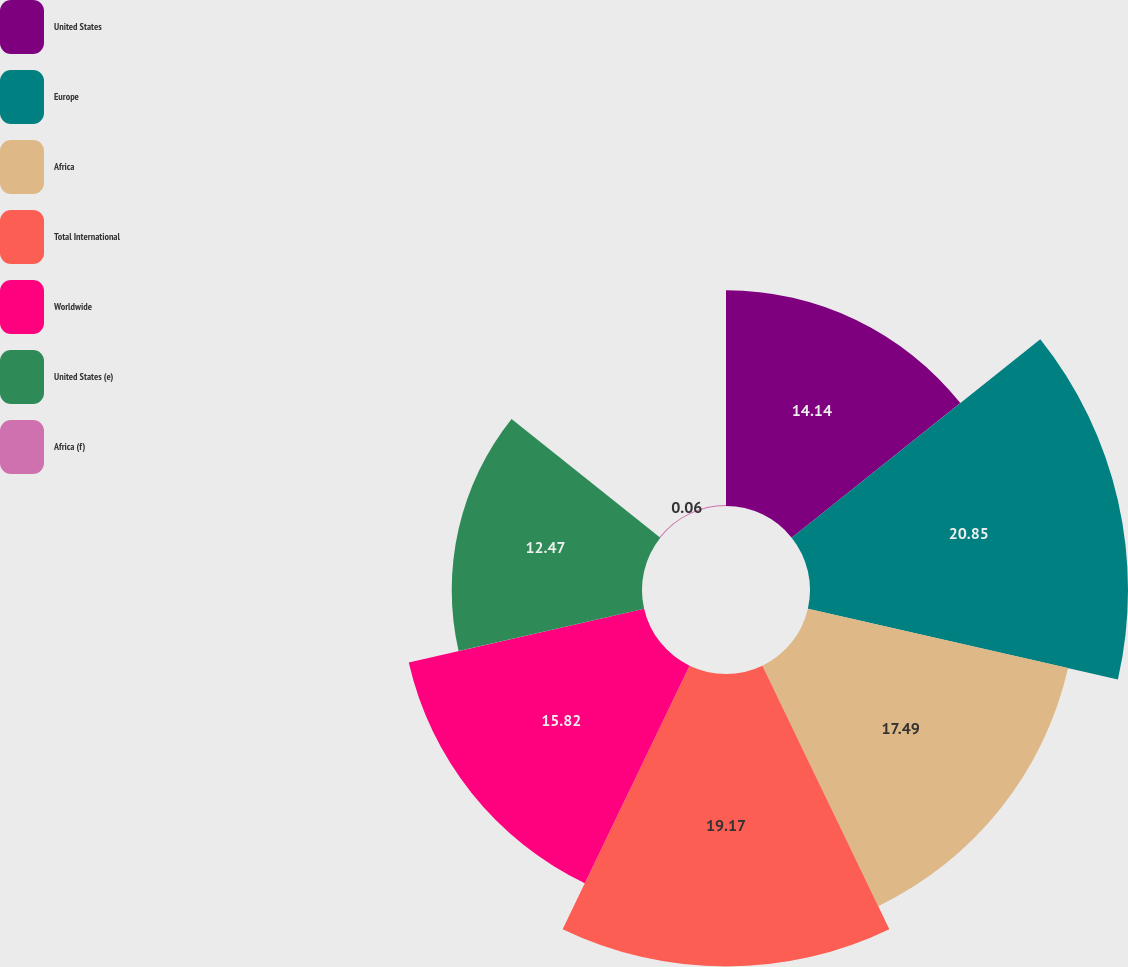Convert chart to OTSL. <chart><loc_0><loc_0><loc_500><loc_500><pie_chart><fcel>United States<fcel>Europe<fcel>Africa<fcel>Total International<fcel>Worldwide<fcel>United States (e)<fcel>Africa (f)<nl><fcel>14.14%<fcel>20.84%<fcel>17.49%<fcel>19.17%<fcel>15.82%<fcel>12.47%<fcel>0.06%<nl></chart> 